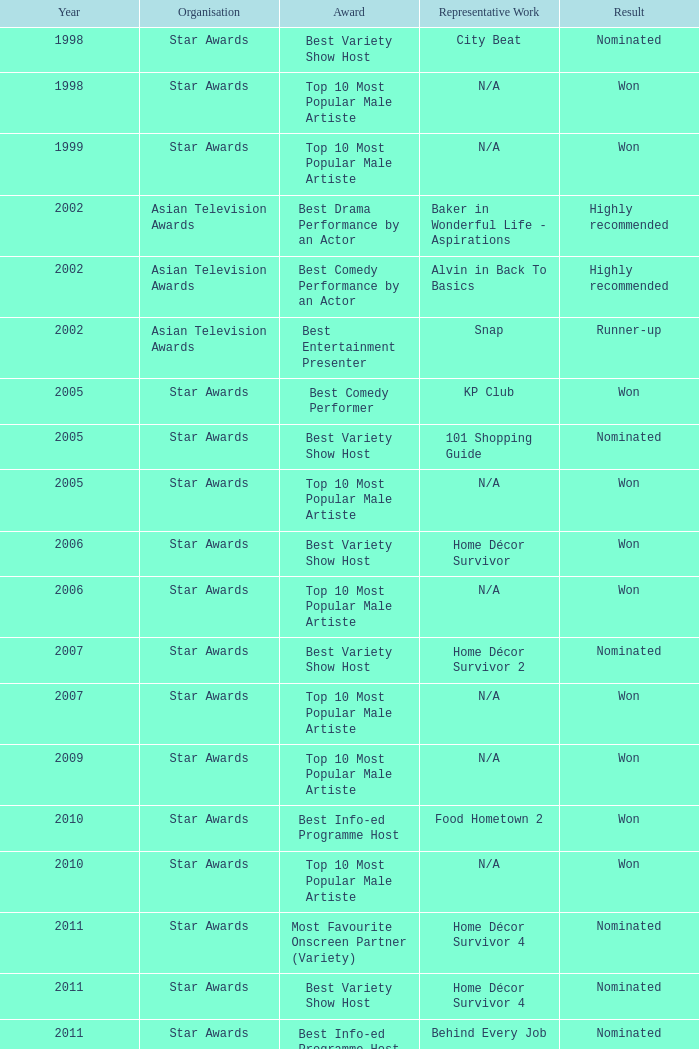What is the name of the representative work in a year post-2005 with a nominated result, and a best variety show host award? Home Décor Survivor 2, Home Décor Survivor 4, Rénaissance, Jobs Around The World. 